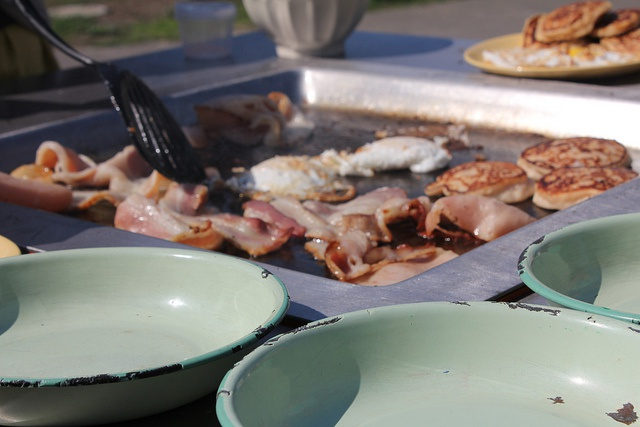Describe the objects in this image and their specific colors. I can see bowl in black, darkgray, teal, and lightgray tones, bowl in black, darkgray, lightgray, and gray tones, bowl in black, gray, darkgray, and turquoise tones, cup in black, gray, and darkgray tones, and cup in black, gray, and navy tones in this image. 